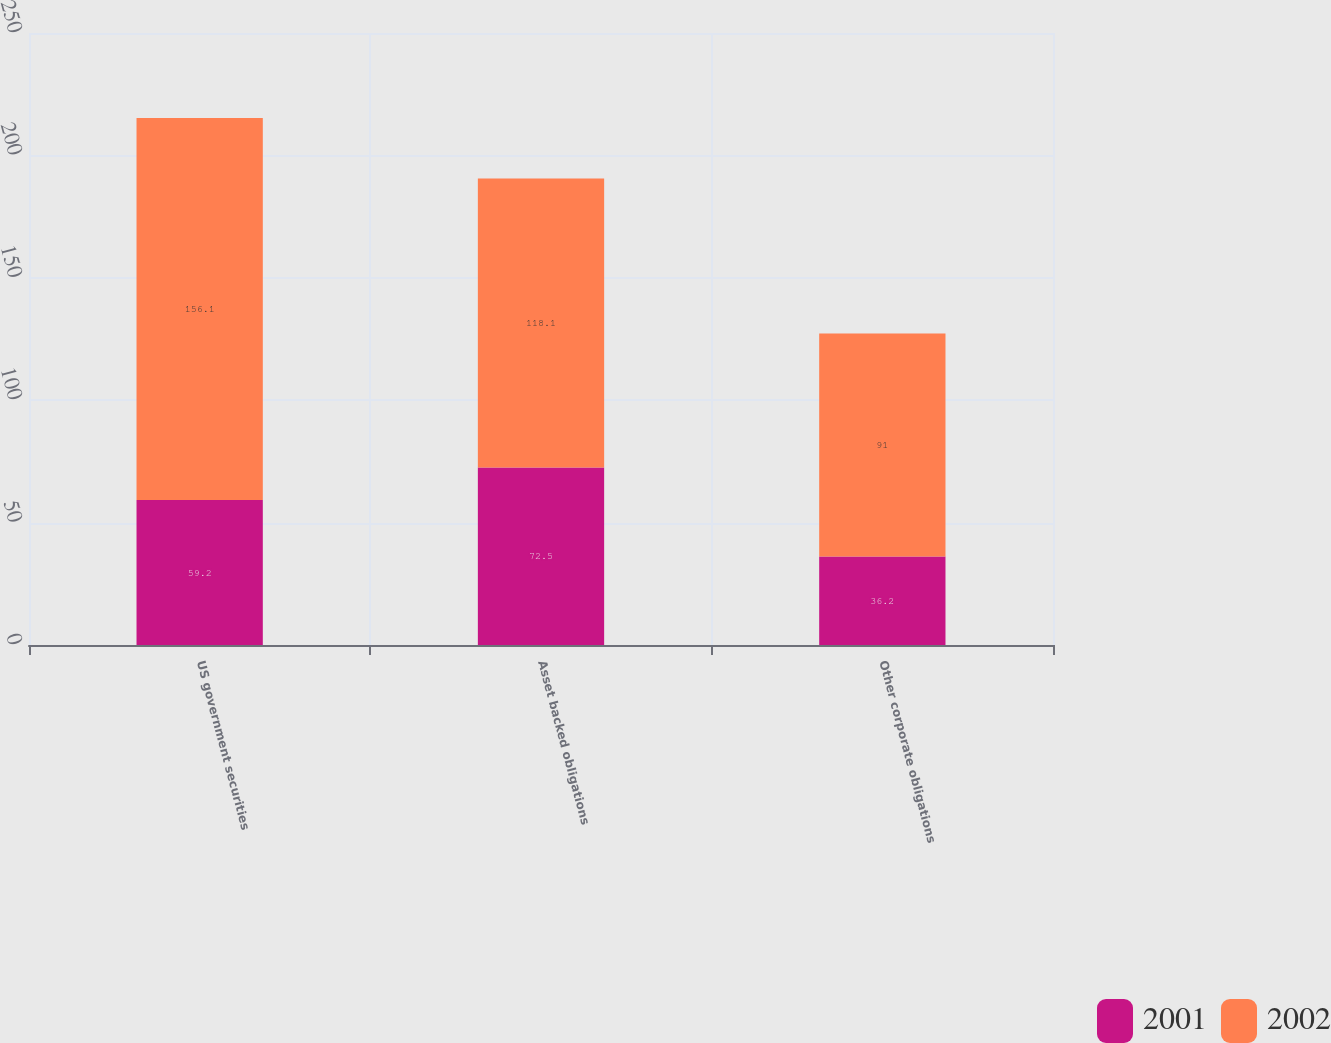Convert chart to OTSL. <chart><loc_0><loc_0><loc_500><loc_500><stacked_bar_chart><ecel><fcel>US government securities<fcel>Asset backed obligations<fcel>Other corporate obligations<nl><fcel>2001<fcel>59.2<fcel>72.5<fcel>36.2<nl><fcel>2002<fcel>156.1<fcel>118.1<fcel>91<nl></chart> 